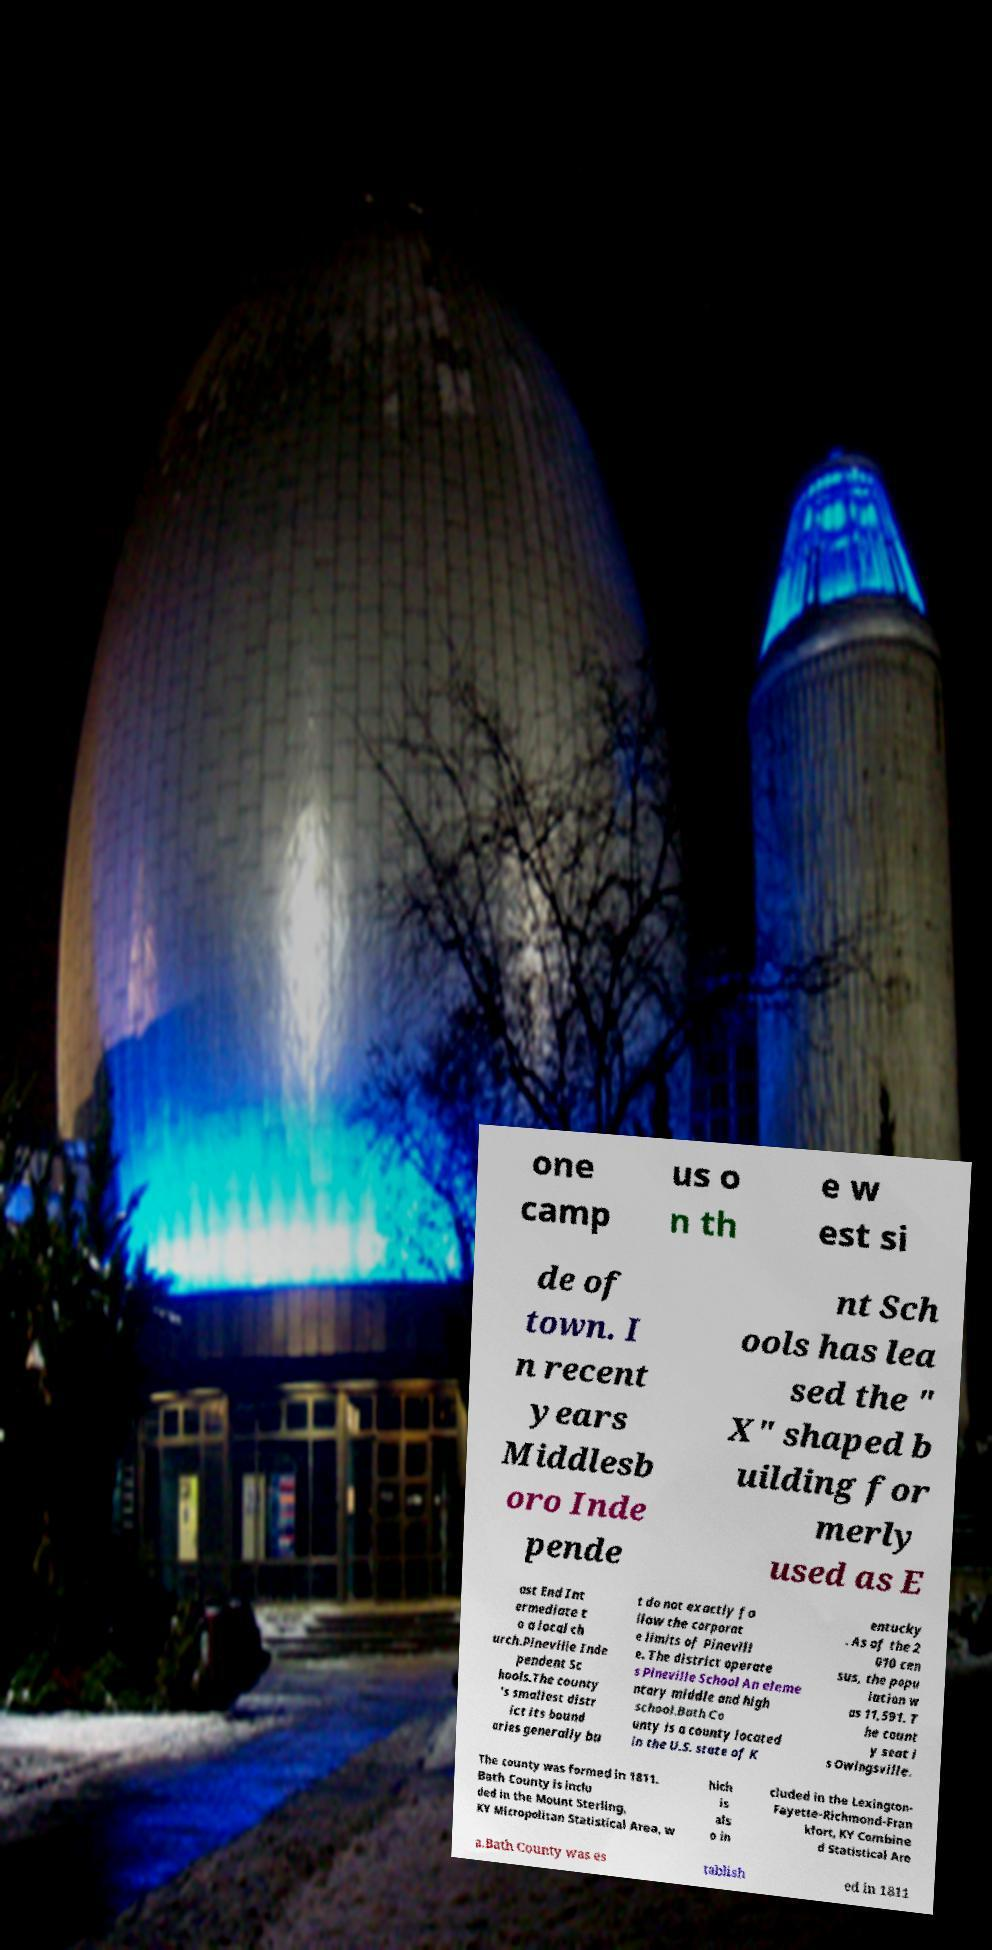There's text embedded in this image that I need extracted. Can you transcribe it verbatim? one camp us o n th e w est si de of town. I n recent years Middlesb oro Inde pende nt Sch ools has lea sed the " X" shaped b uilding for merly used as E ast End Int ermediate t o a local ch urch.Pineville Inde pendent Sc hools.The county 's smallest distr ict its bound aries generally bu t do not exactly fo llow the corporat e limits of Pinevill e. The district operate s Pineville School An eleme ntary middle and high school.Bath Co unty is a county located in the U.S. state of K entucky . As of the 2 010 cen sus, the popu lation w as 11,591. T he count y seat i s Owingsville. The county was formed in 1811. Bath County is inclu ded in the Mount Sterling, KY Micropolitan Statistical Area, w hich is als o in cluded in the Lexington- Fayette-Richmond-Fran kfort, KY Combine d Statistical Are a.Bath County was es tablish ed in 1811 